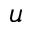Convert formula to latex. <formula><loc_0><loc_0><loc_500><loc_500>u</formula> 